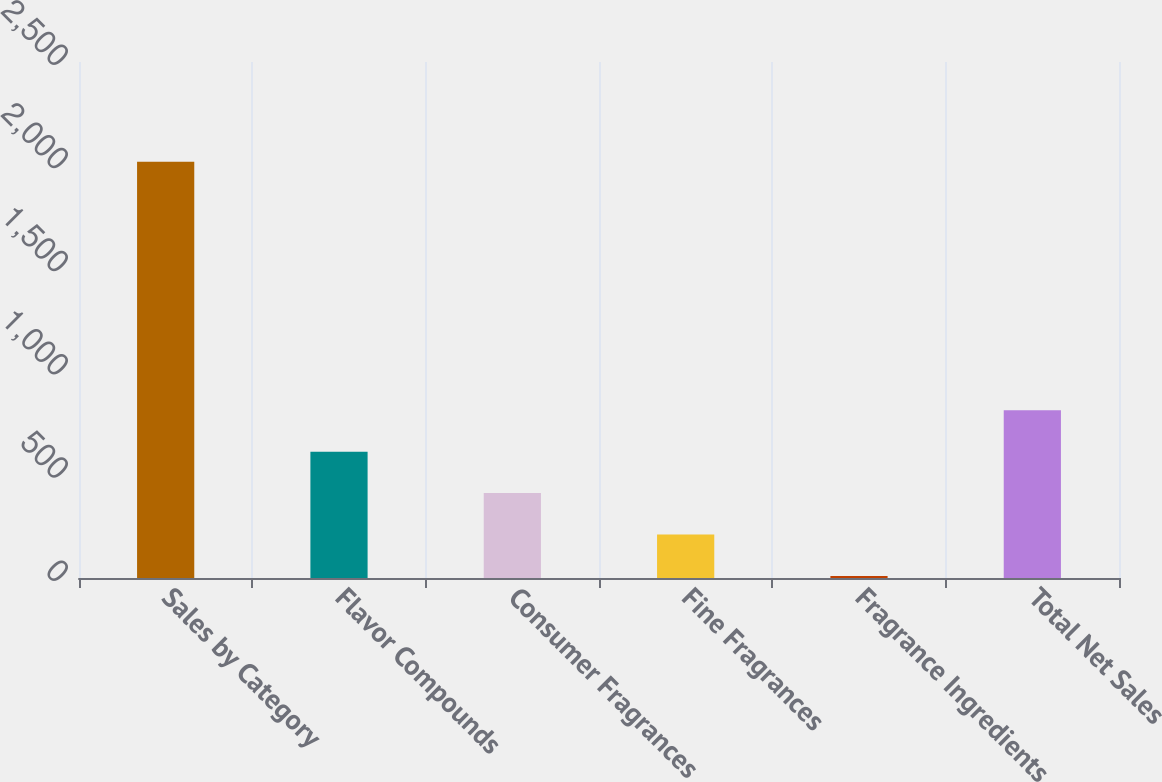<chart> <loc_0><loc_0><loc_500><loc_500><bar_chart><fcel>Sales by Category<fcel>Flavor Compounds<fcel>Consumer Fragrances<fcel>Fine Fragrances<fcel>Fragrance Ingredients<fcel>Total Net Sales<nl><fcel>2017<fcel>612.1<fcel>411.4<fcel>210.7<fcel>10<fcel>812.8<nl></chart> 